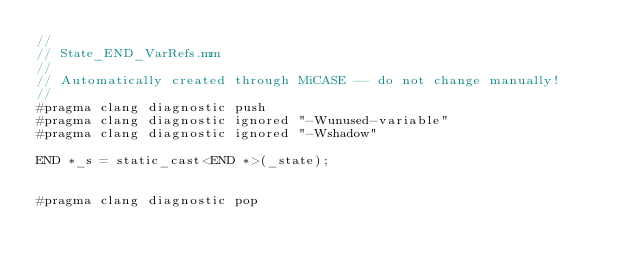Convert code to text. <code><loc_0><loc_0><loc_500><loc_500><_ObjectiveC_>//
// State_END_VarRefs.mm
//
// Automatically created through MiCASE -- do not change manually!
//
#pragma clang diagnostic push
#pragma clang diagnostic ignored "-Wunused-variable"
#pragma clang diagnostic ignored "-Wshadow"

END *_s = static_cast<END *>(_state);


#pragma clang diagnostic pop
</code> 